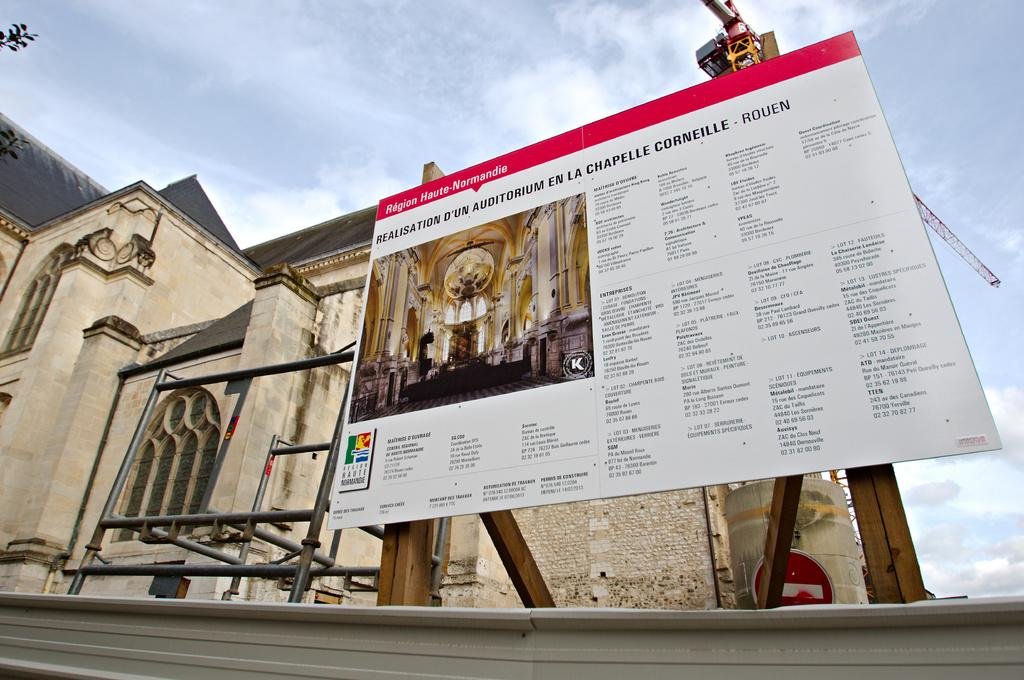<image>
Present a compact description of the photo's key features. Large white board which says "Region Haute-Normandie" on the top. 